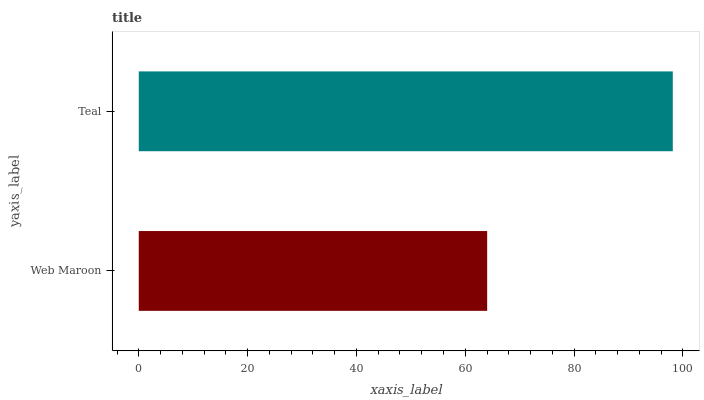Is Web Maroon the minimum?
Answer yes or no. Yes. Is Teal the maximum?
Answer yes or no. Yes. Is Teal the minimum?
Answer yes or no. No. Is Teal greater than Web Maroon?
Answer yes or no. Yes. Is Web Maroon less than Teal?
Answer yes or no. Yes. Is Web Maroon greater than Teal?
Answer yes or no. No. Is Teal less than Web Maroon?
Answer yes or no. No. Is Teal the high median?
Answer yes or no. Yes. Is Web Maroon the low median?
Answer yes or no. Yes. Is Web Maroon the high median?
Answer yes or no. No. Is Teal the low median?
Answer yes or no. No. 